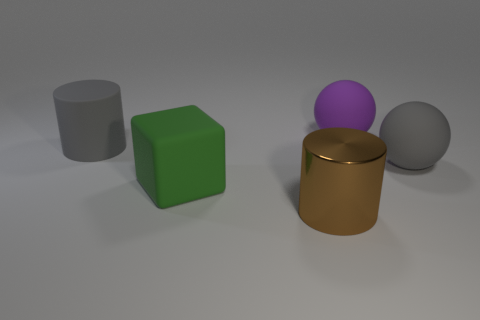Is there any other thing that is the same material as the big brown cylinder?
Give a very brief answer. No. What material is the big gray thing that is to the left of the gray ball?
Make the answer very short. Rubber. How many metal objects are brown cylinders or large purple objects?
Ensure brevity in your answer.  1. What color is the cylinder in front of the big gray matte ball that is behind the brown object?
Keep it short and to the point. Brown. Do the brown thing and the cylinder that is behind the large brown cylinder have the same material?
Provide a short and direct response. No. There is a cylinder behind the gray object that is in front of the gray rubber thing that is to the left of the block; what color is it?
Make the answer very short. Gray. Is there anything else that is the same shape as the big green thing?
Give a very brief answer. No. Are there more big cyan metallic cylinders than large rubber blocks?
Provide a succinct answer. No. How many large objects are both in front of the gray ball and behind the gray ball?
Give a very brief answer. 0. What number of big gray things are in front of the large gray matte thing that is on the right side of the purple matte sphere?
Your response must be concise. 0. 